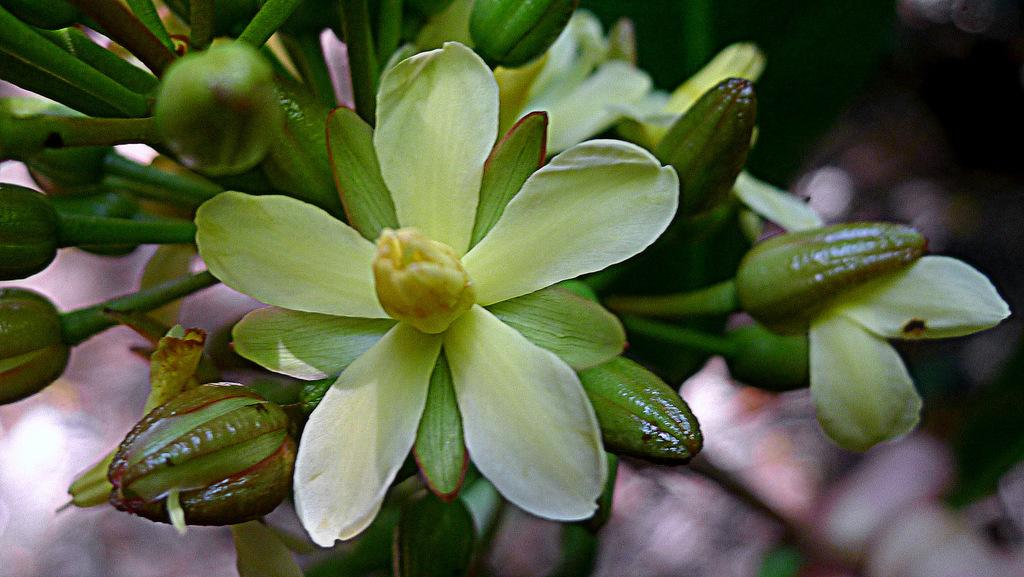What type of plants can be seen in the image? There are flowers in the image. Can you describe the stage of growth for some of the plants? Yes, there are buds in the image. What is the appearance of the background in the image? The background of the image is blurred. What type of suit is the doctor wearing in the image? There is no doctor or suit present in the image; it features flowers and buds with a blurred background. 